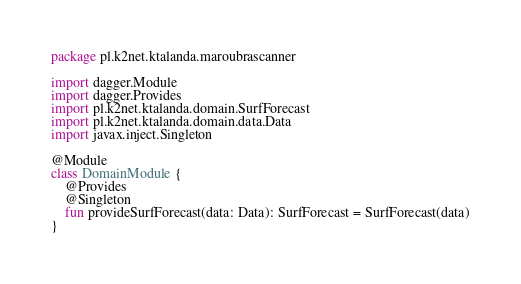Convert code to text. <code><loc_0><loc_0><loc_500><loc_500><_Kotlin_>package pl.k2net.ktalanda.maroubrascanner

import dagger.Module
import dagger.Provides
import pl.k2net.ktalanda.domain.SurfForecast
import pl.k2net.ktalanda.domain.data.Data
import javax.inject.Singleton

@Module
class DomainModule {
    @Provides
    @Singleton
    fun provideSurfForecast(data: Data): SurfForecast = SurfForecast(data)
}
</code> 